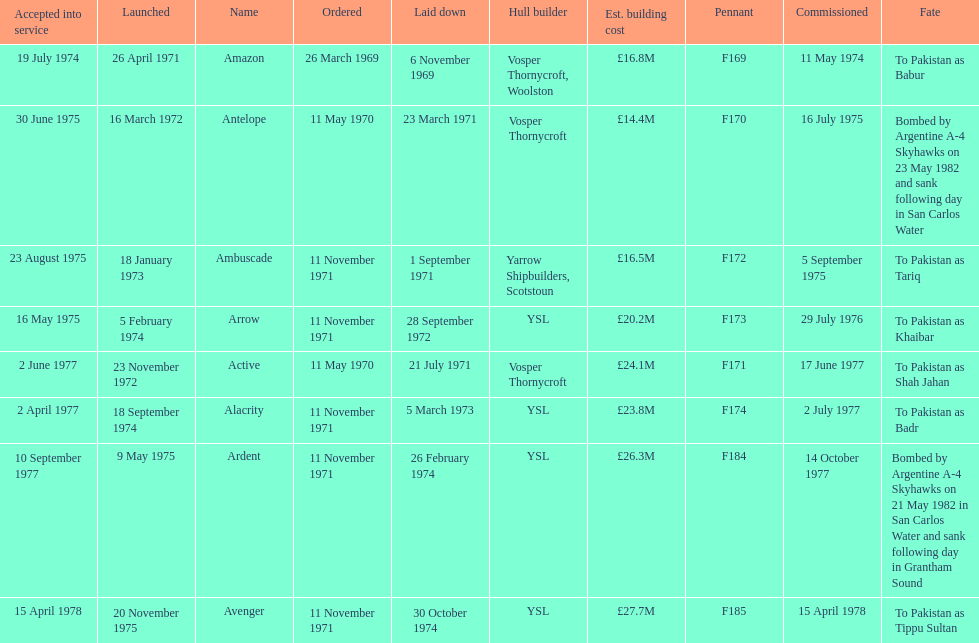How many boats costed less than £20m to build? 3. 